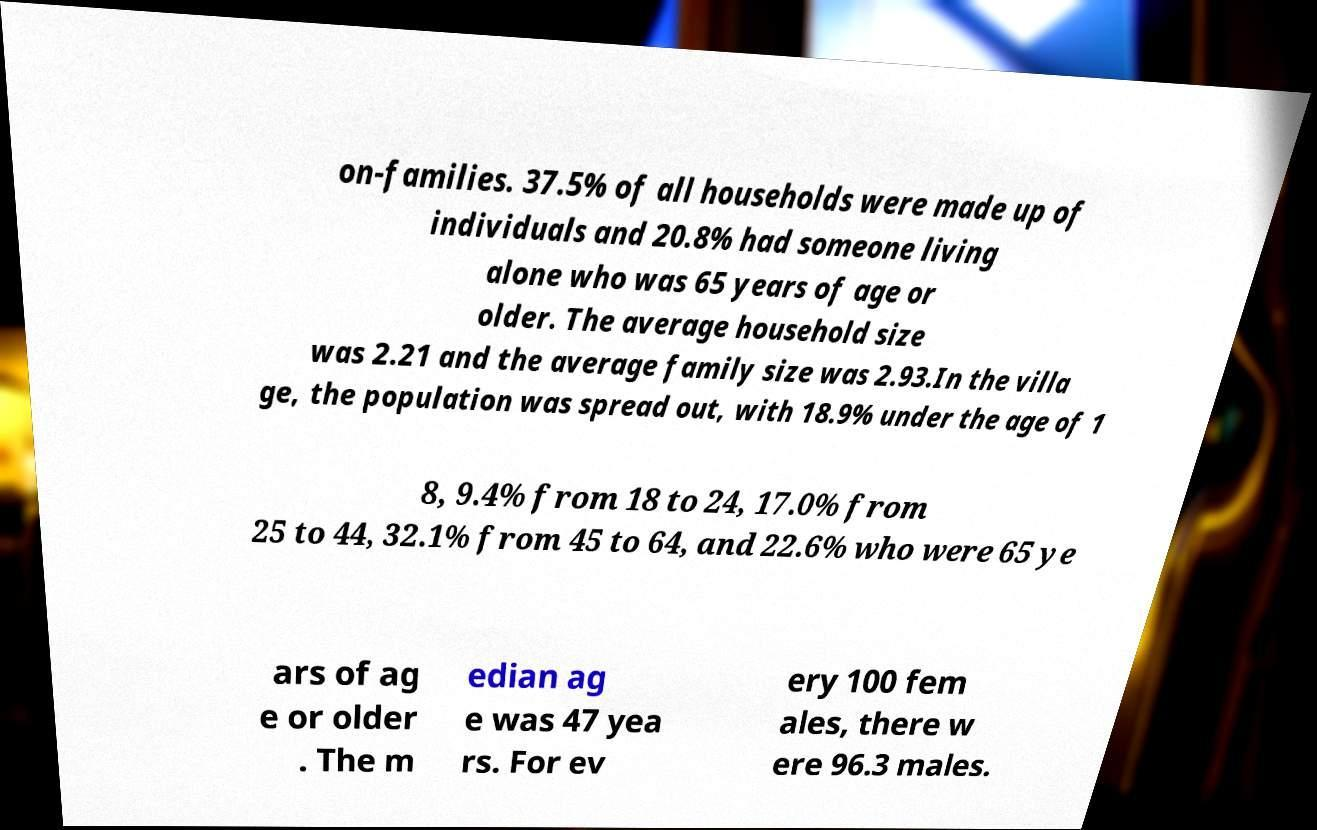Please read and relay the text visible in this image. What does it say? on-families. 37.5% of all households were made up of individuals and 20.8% had someone living alone who was 65 years of age or older. The average household size was 2.21 and the average family size was 2.93.In the villa ge, the population was spread out, with 18.9% under the age of 1 8, 9.4% from 18 to 24, 17.0% from 25 to 44, 32.1% from 45 to 64, and 22.6% who were 65 ye ars of ag e or older . The m edian ag e was 47 yea rs. For ev ery 100 fem ales, there w ere 96.3 males. 